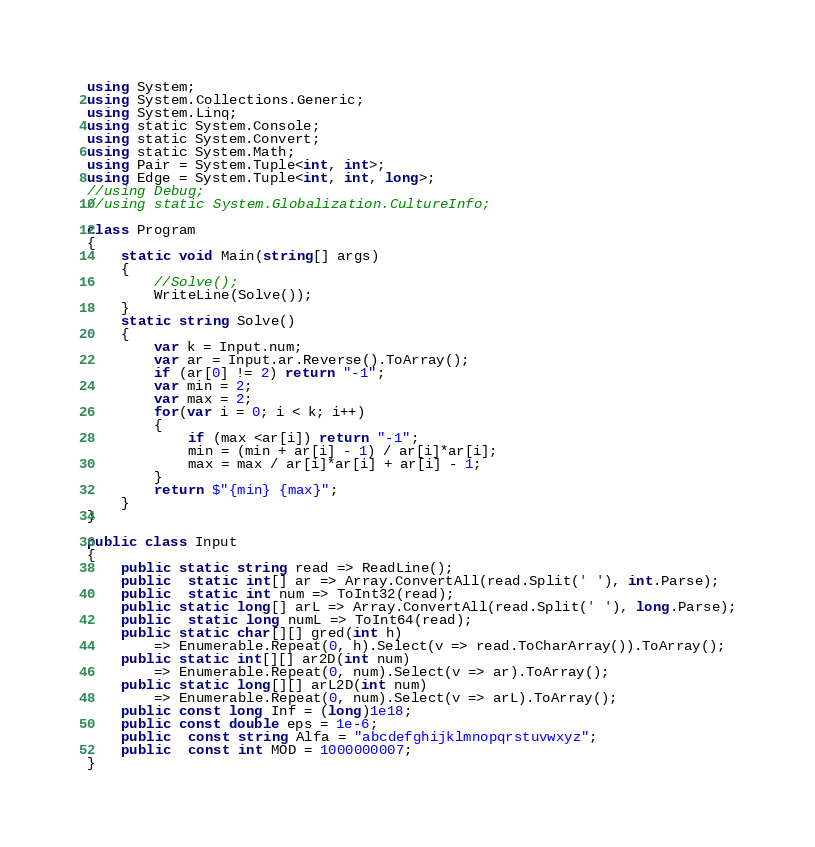Convert code to text. <code><loc_0><loc_0><loc_500><loc_500><_C#_>using System;
using System.Collections.Generic;
using System.Linq;
using static System.Console;
using static System.Convert;
using static System.Math;
using Pair = System.Tuple<int, int>;
using Edge = System.Tuple<int, int, long>;
//using Debug;
//using static System.Globalization.CultureInfo;

class Program
{
    static void Main(string[] args)
    {
        //Solve();
        WriteLine(Solve());
    }
    static string Solve()
    {
        var k = Input.num;
        var ar = Input.ar.Reverse().ToArray();
        if (ar[0] != 2) return "-1";
        var min = 2;
        var max = 2;
        for(var i = 0; i < k; i++)
        {
            if (max <ar[i]) return "-1";
            min = (min + ar[i] - 1) / ar[i]*ar[i];
            max = max / ar[i]*ar[i] + ar[i] - 1;
        }
        return $"{min} {max}";
    }
}

public class Input
{
    public static string read => ReadLine();
    public  static int[] ar => Array.ConvertAll(read.Split(' '), int.Parse);
    public  static int num => ToInt32(read);
    public static long[] arL => Array.ConvertAll(read.Split(' '), long.Parse);
    public  static long numL => ToInt64(read);
    public static char[][] gred(int h) 
        => Enumerable.Repeat(0, h).Select(v => read.ToCharArray()).ToArray();
    public static int[][] ar2D(int num)
        => Enumerable.Repeat(0, num).Select(v => ar).ToArray();
    public static long[][] arL2D(int num)
        => Enumerable.Repeat(0, num).Select(v => arL).ToArray();
    public const long Inf = (long)1e18;
    public const double eps = 1e-6;
    public  const string Alfa = "abcdefghijklmnopqrstuvwxyz";
    public  const int MOD = 1000000007;
}
</code> 